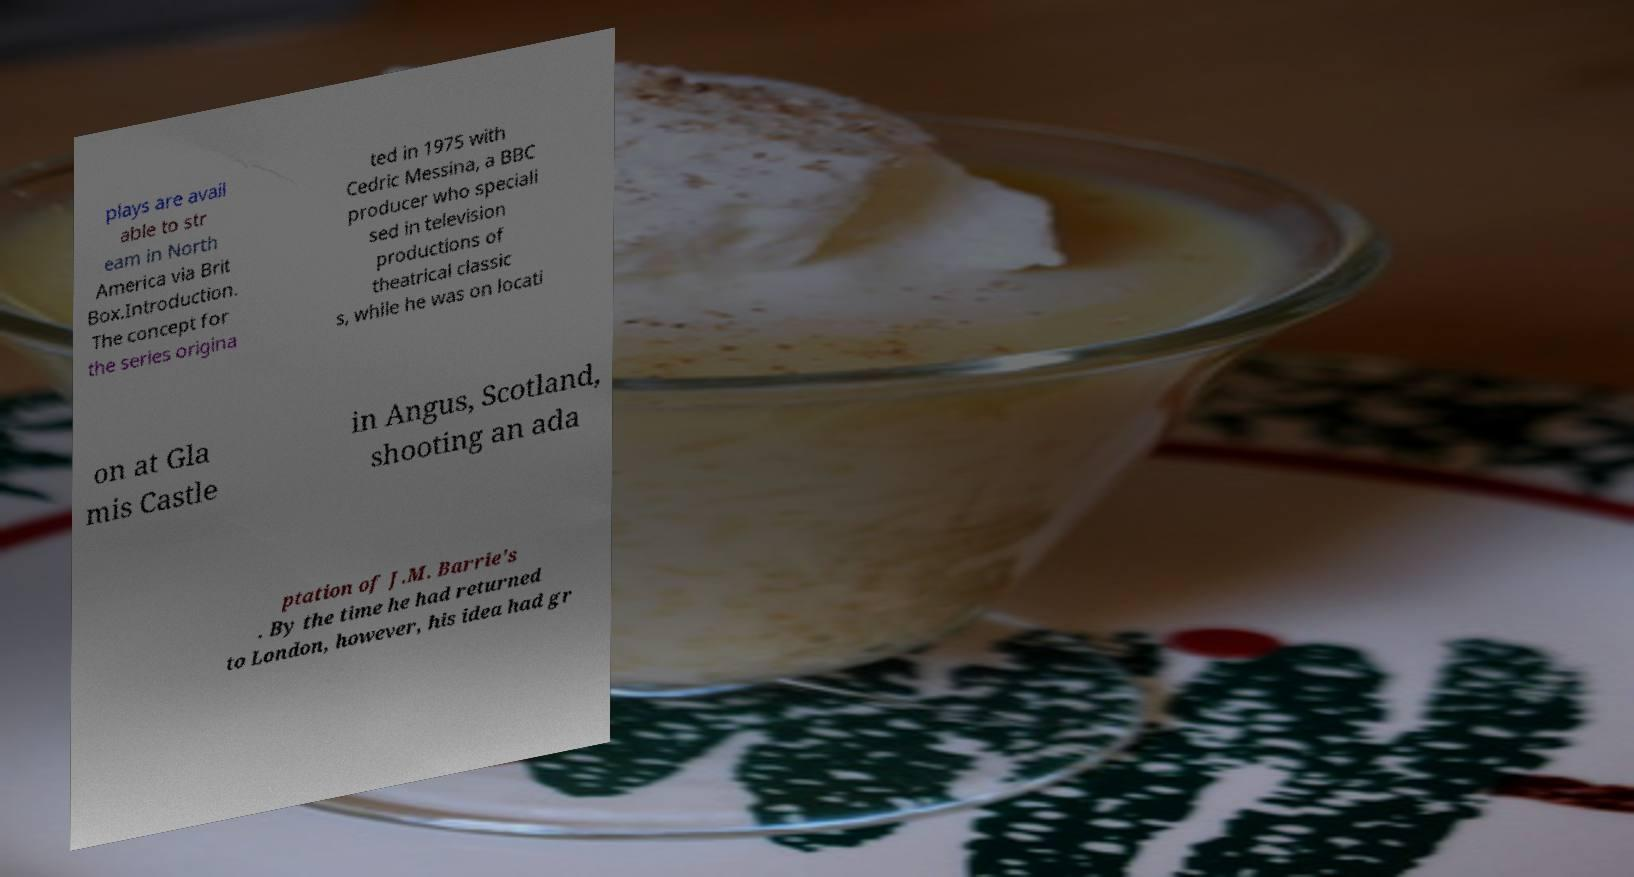Please identify and transcribe the text found in this image. plays are avail able to str eam in North America via Brit Box.Introduction. The concept for the series origina ted in 1975 with Cedric Messina, a BBC producer who speciali sed in television productions of theatrical classic s, while he was on locati on at Gla mis Castle in Angus, Scotland, shooting an ada ptation of J.M. Barrie's . By the time he had returned to London, however, his idea had gr 